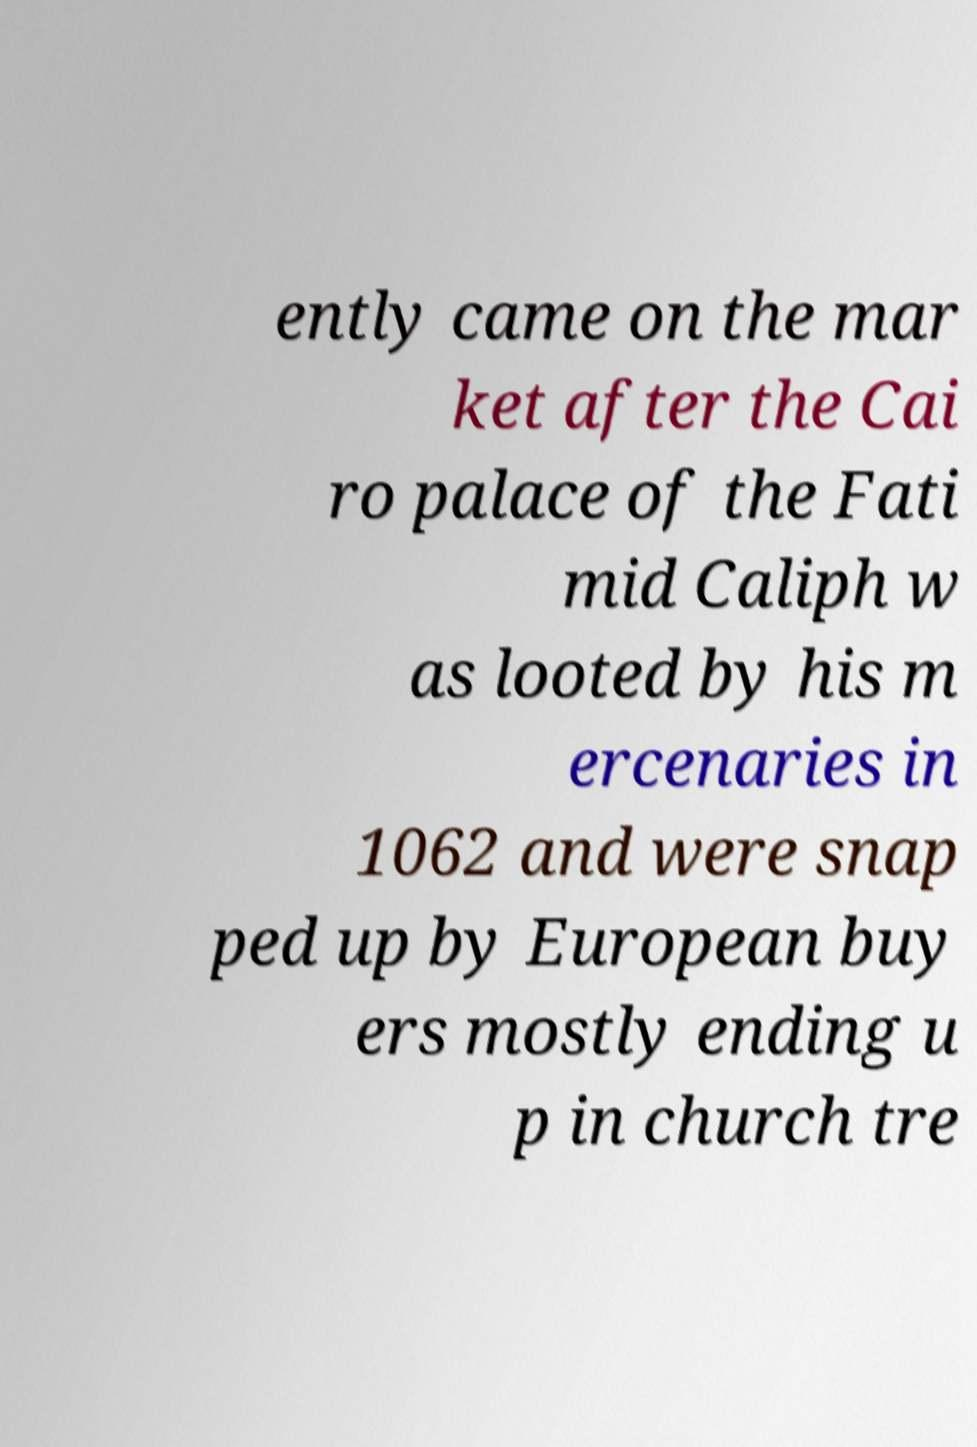Could you assist in decoding the text presented in this image and type it out clearly? ently came on the mar ket after the Cai ro palace of the Fati mid Caliph w as looted by his m ercenaries in 1062 and were snap ped up by European buy ers mostly ending u p in church tre 